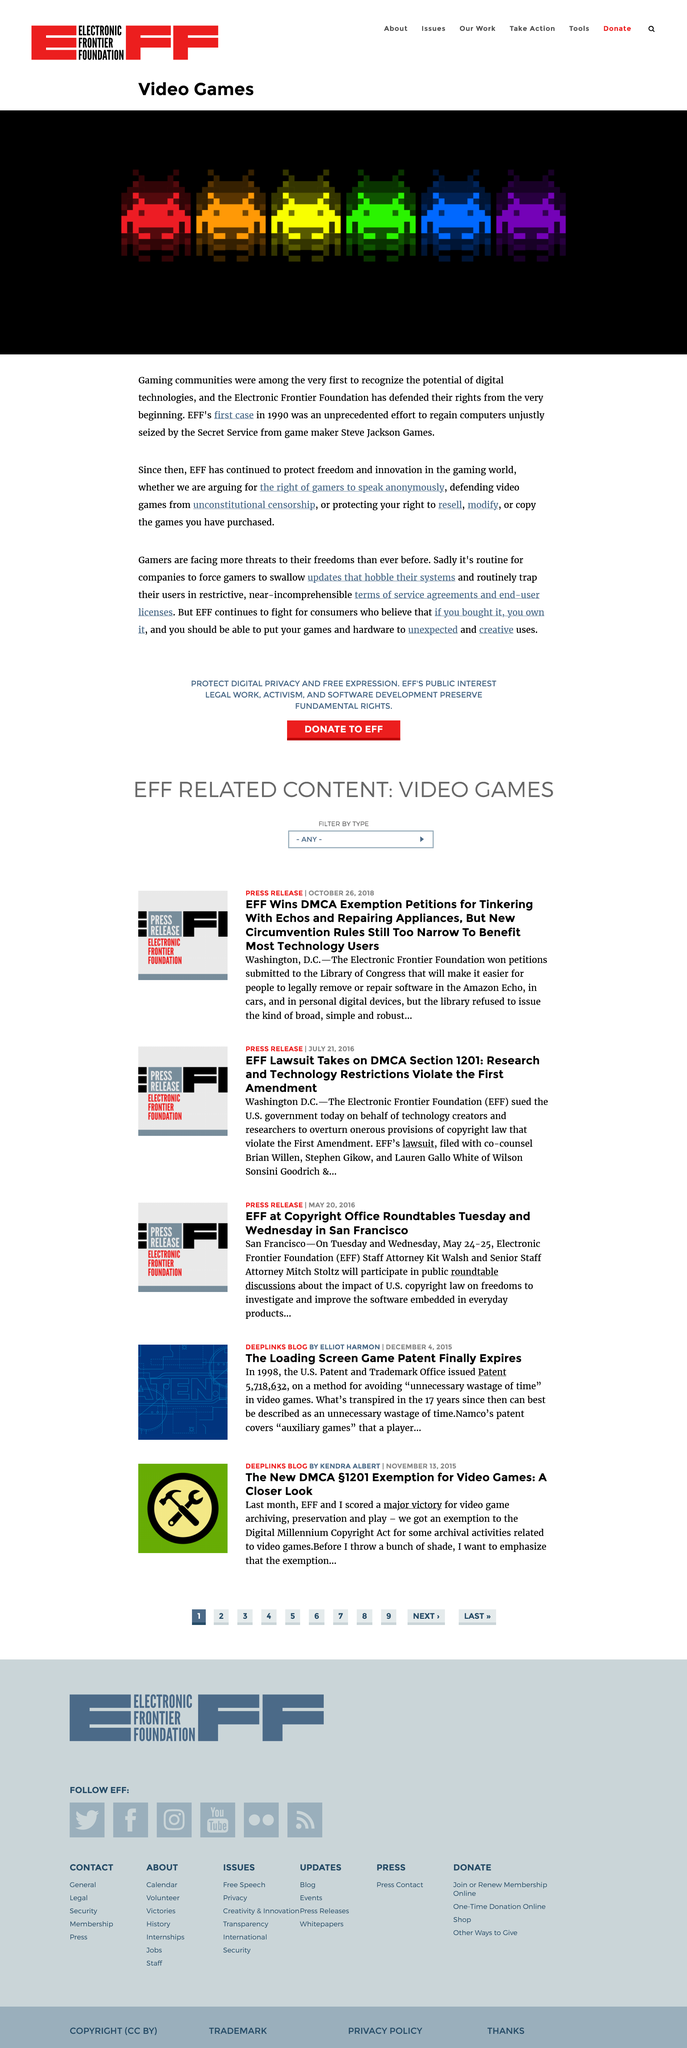Specify some key components in this picture. The topic of discussion is video games. The title of the page is "video games". The EFF's first case was in 1990. 